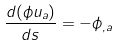<formula> <loc_0><loc_0><loc_500><loc_500>\frac { d ( \phi u _ { a } ) } { d s } = - \phi _ { , a }</formula> 